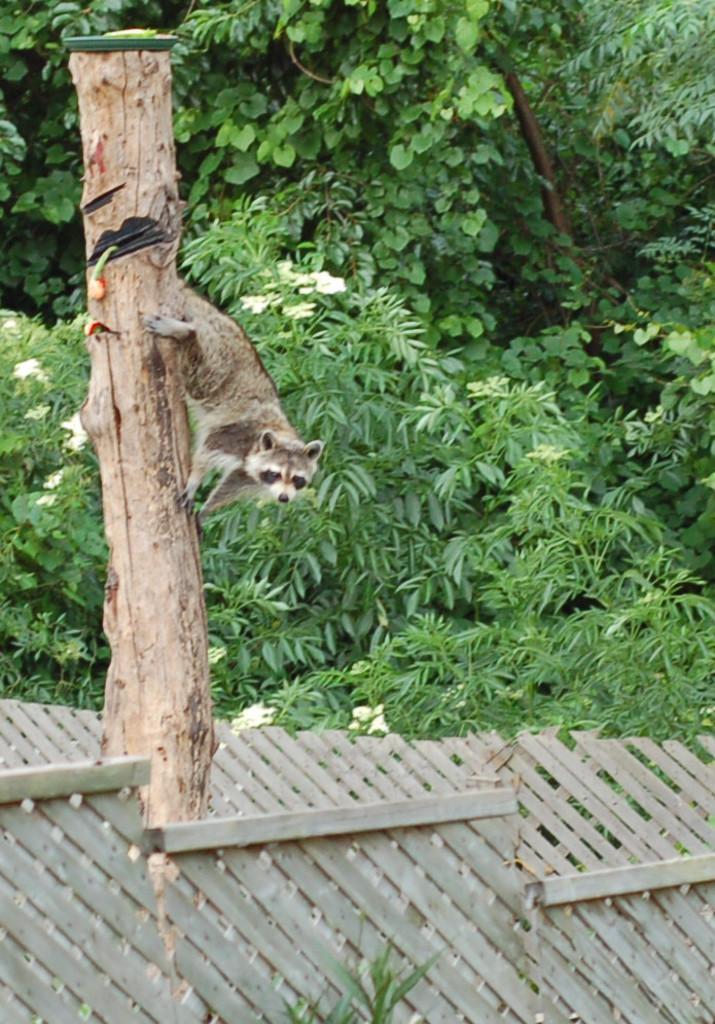Please provide a concise description of this image. In this image I can see an animal which is in white,brown and black color. Animal is on the branch. Back Side I can see green trees. In front I can see a cream color fencing. 